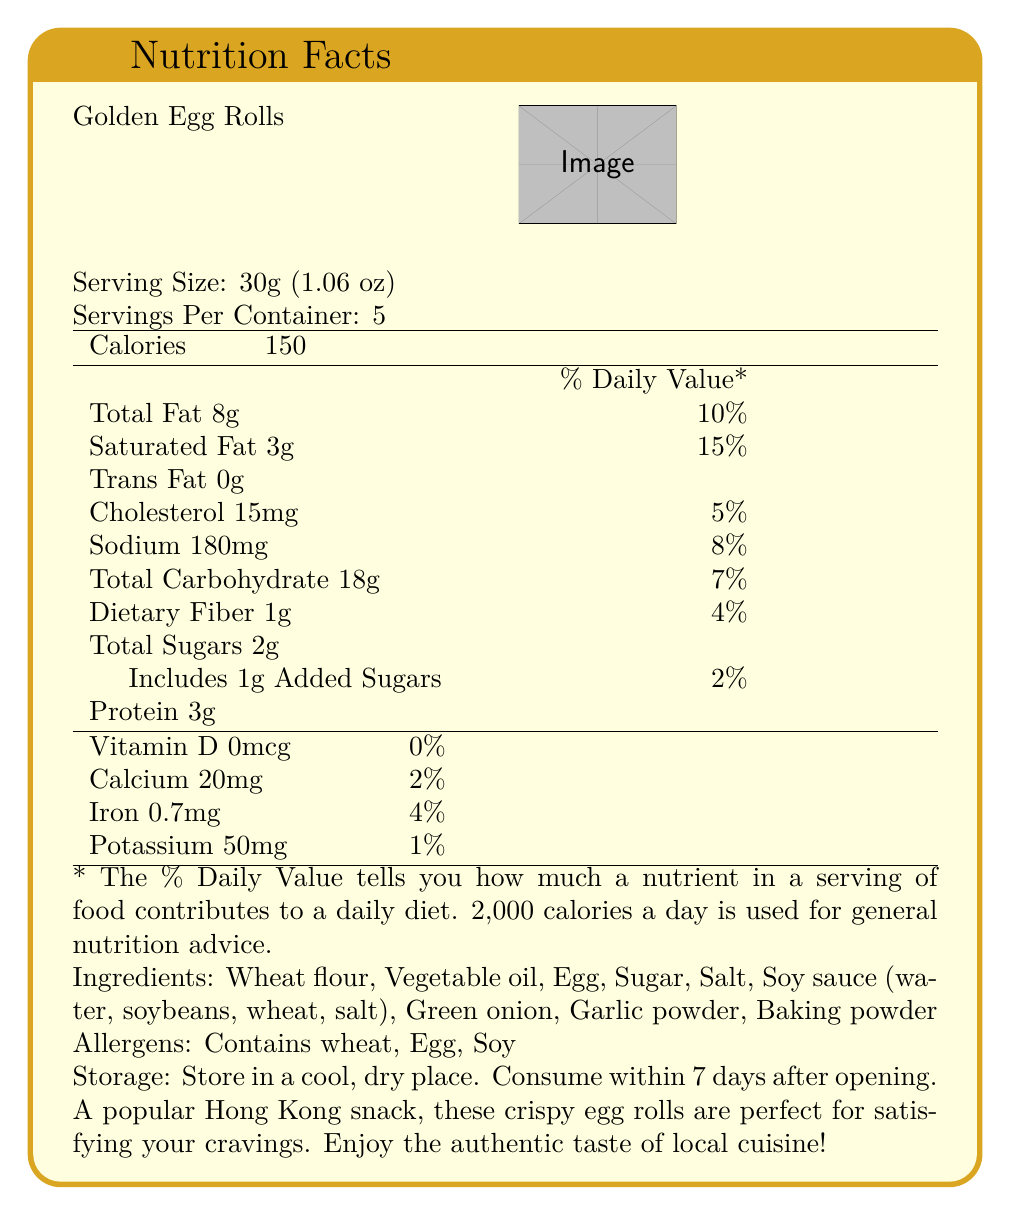What is the serving size of the Golden Egg Rolls in grams? The serving size is listed under "Serving Size," indicating 30 grams (1.06 oz).
Answer: 30 grams How many servings are there per container? The number of servings per container is clearly listed as 5.
Answer: 5 servings How many calories are in one serving? The number of calories per serving is listed as 150 under the "Calories" section.
Answer: 150 calories What is the percentage of daily value for saturated fat? The % Daily Value for saturated fat is listed as 15% next to the Saturated Fat content.
Answer: 15% What allergens does this product contain? The allergens are listed at the bottom under "Allergens."
Answer: Wheat, Egg, Soy Which nutrient contributes the highest percentage of the daily value? A. Total Fat B. Cholesterol C. Sodium D. Saturated Fat The saturated fat contributes 15% of the daily value, which is higher than the other listed nutrients.
Answer: D. Saturated Fat What is the total carbohydrate content in grams? The total carbohydrate content is listed as 18 grams per serving.
Answer: 18 grams How much dietary fiber is in one serving? The dietary fiber content is listed as 1 gram per serving.
Answer: 1 gram Does this product contain trans fat? The trans fat content is listed as 0 grams.
Answer: No What is the storage instruction for this product? The storage instructions are specified towards the bottom section of the document.
Answer: Store in a cool, dry place. Consume within 7 days after opening. What is the sodium content per serving? The sodium content is listed as 180 milligrams per serving under the Sodium section.
Answer: 180 milligrams Which ingredients are included in the Golden Egg Rolls? A. Wheat flour, Egg, Sugar, Green onion B. Wheat flour, Vegetable oil, Sugar, Salt C. Wheat flour, Egg, Salt, Baking powder D. All of the above All of the mentioned options are ingredients listed under the Ingredients section.
Answer: D. All of the above Are there any added sugars in this product? The label indicates that 1 gram of the total 2 grams of sugar is added sugar.
Answer: Yes Which vitamin is not present in the Golden Egg Rolls? The Vitamin D content is listed as 0 micrograms with 0% Daily Value.
Answer: Vitamin D How much protein is in one serving of Golden Egg Rolls? The protein content per serving is listed as 3 grams.
Answer: 3 grams What should you do if you cannot finish the product within 7 days of opening? The document does not provide information on what to do if the product cannot be finished within 7 days.
Answer: This information is not provided. Summarize the main idea of the document. The document gives essential nutritional information and storage directions for consumers, ensuring they understand what they are consuming and how to properly store the product.
Answer: The document provides detailed Nutrition Facts for Golden Egg Rolls produced by Hong Kong Snacks Co., Ltd., including serving size, number of servings per container, caloric content, amounts of various nutrients, ingredients, allergens, and storage instructions, along with a brief product description and cultural insight about egg rolls in Hong Kong. Are Golden Egg Rolls considered high in potassium based on the % Daily Value? The potassium content is 1% of the Daily Value, which is relatively low.
Answer: No 